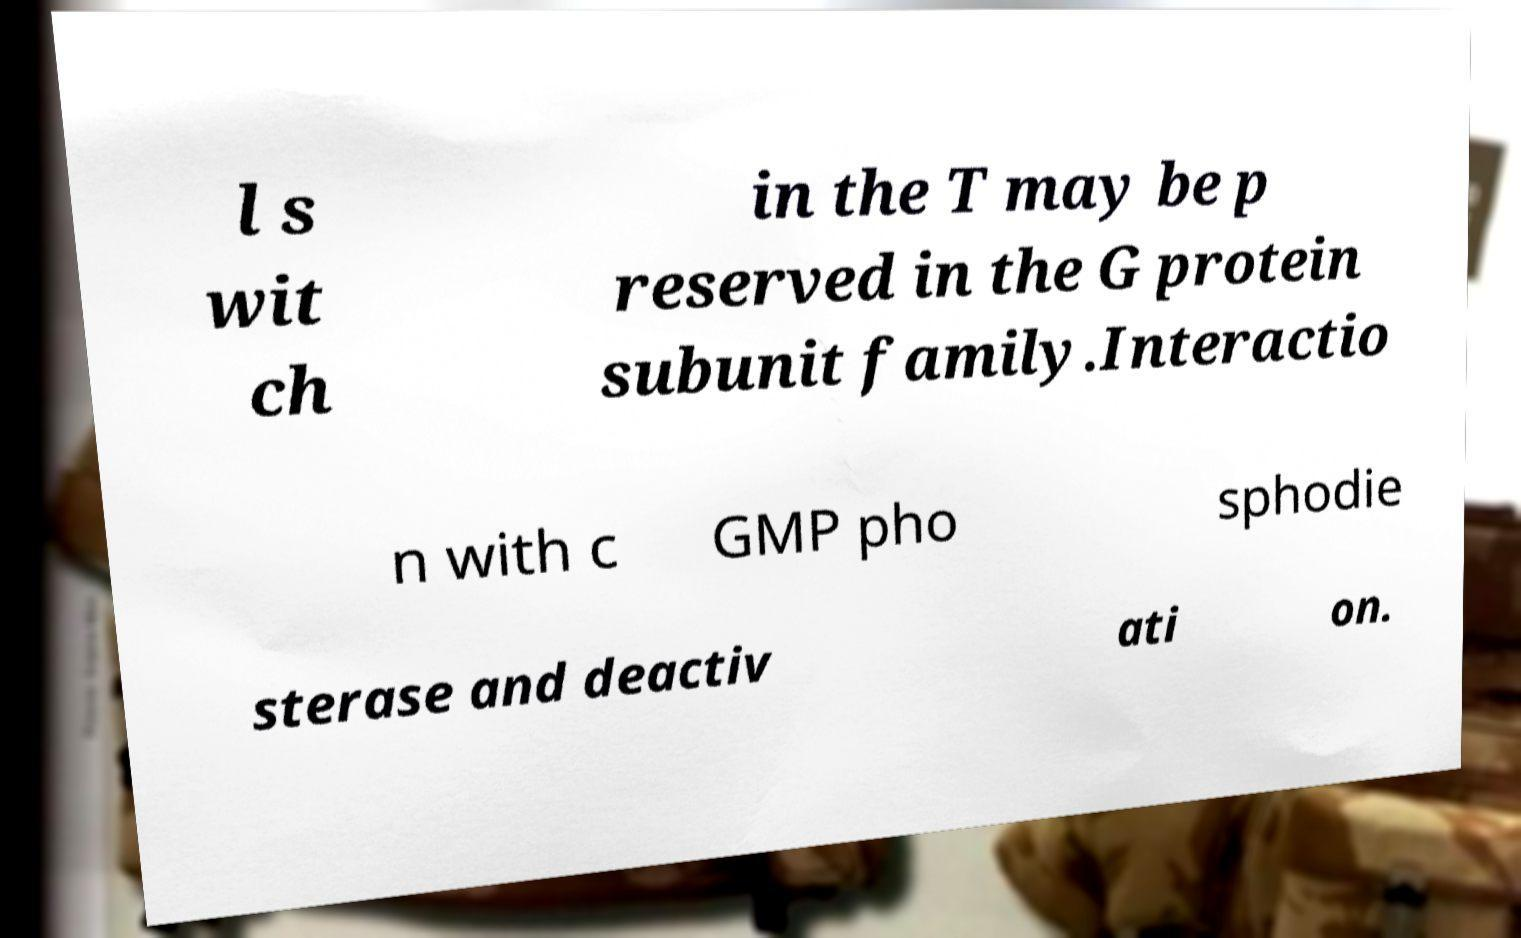Can you accurately transcribe the text from the provided image for me? l s wit ch in the T may be p reserved in the G protein subunit family.Interactio n with c GMP pho sphodie sterase and deactiv ati on. 